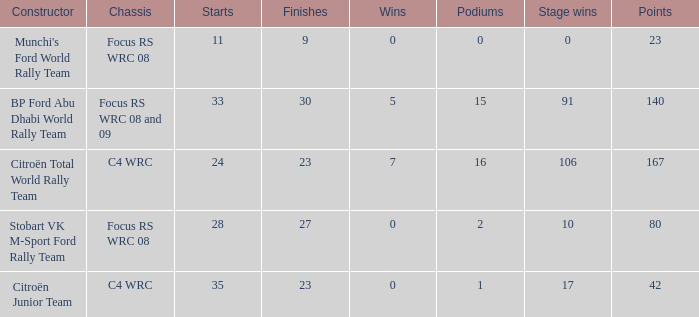What is the average wins when the podiums is more than 1, points is 80 and starts is less than 28? None. 